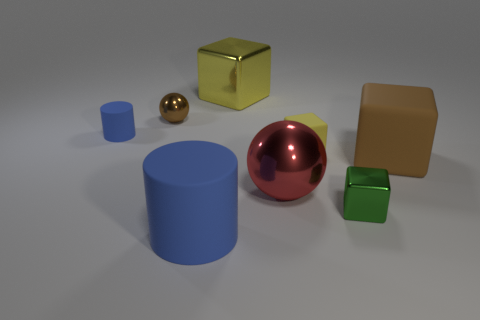Subtract all large brown blocks. How many blocks are left? 3 Add 2 tiny blue cylinders. How many objects exist? 10 Subtract all red balls. How many balls are left? 1 Subtract all balls. How many objects are left? 6 Subtract all cyan cylinders. Subtract all brown spheres. How many cylinders are left? 2 Subtract all purple balls. How many brown cylinders are left? 0 Subtract all yellow rubber blocks. Subtract all blue matte things. How many objects are left? 5 Add 4 yellow cubes. How many yellow cubes are left? 6 Add 2 big blue metal objects. How many big blue metal objects exist? 2 Subtract 1 brown balls. How many objects are left? 7 